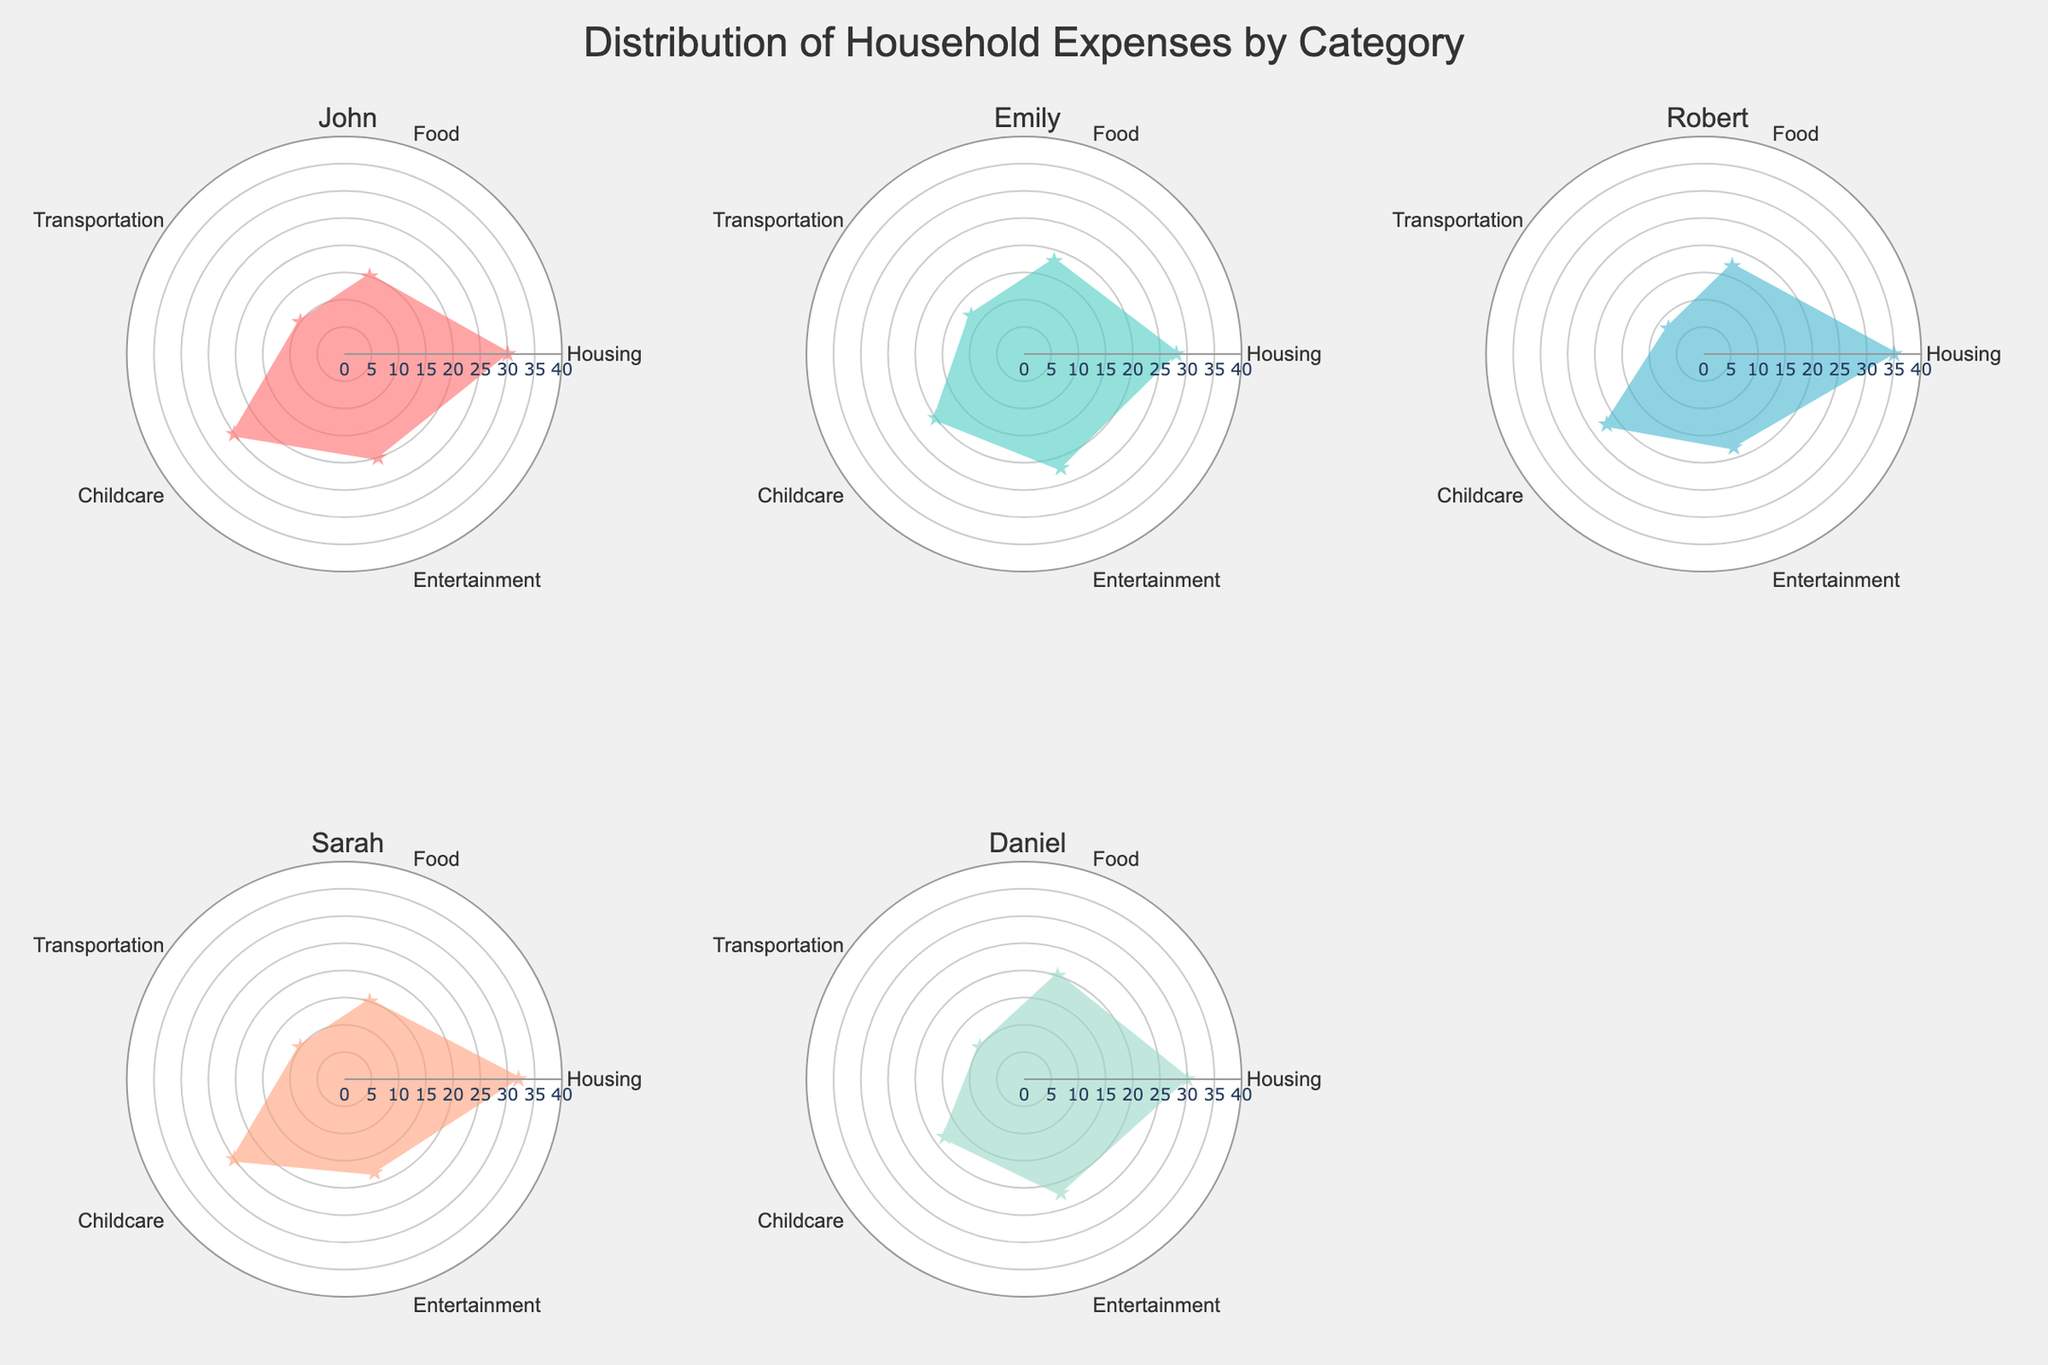What's the title of the figure? The title is located at the top center of the figure and displays the overall topic of the data presented.
Answer: Distribution of Household Expenses by Category How many individuals' household expenses are compared in the figure? By counting the number of subplot titles, one for each individual, we can determine the number of individuals.
Answer: 5 Which individual spends the most on Housing? By comparing the values of Housing for each individual, the one with the highest value is identified. Robert spends 35% on Housing, which is the highest.
Answer: Robert What is the total percentage of expenses for Emily in Food and Childcare? To determine this, add Emily's percentage in Food (18) and Childcare (20).
Answer: 38% Which category has the highest average percentage of expense across all individuals? First, compute the average percentage for each category. Housing: (30+28+35+32+30)/5 = 31, Food: (15+18+17+15+20)/5 = 17, Transportation: (10+12+8+10+10)/5 = 10, Childcare: (25+20+22+25+18)/5 = 22, Entertainment: (20+22+18+18+22)/5 = 20. Then, compare these averages.
Answer: Housing Whose expenses on Entertainment equal those on Housing? By examining the expenses for Entertainment and Housing for each individual, we find that Sarah spends 18% on both categories.
Answer: Sarah Which category shows the highest variability in expenses among individuals? By examining the data closely, we will determine the category with the widest range of values. Housing varies from 28% to 35%, Food from 15% to 20%, Transportation from 8% to 12%, Childcare from 18% to 25%, and Entertainment from 18% to 22%. The highest variability is in Housing (7%).
Answer: Housing What is the difference between Robert's expenses on Childcare and Transportation? Subtract Robert's percentage on Transportation (8) from Childcare (22).
Answer: 14% Which individual has the most balanced expenses across all categories? By looking at the radar charts, we identify the individual whose data points form the most regular polygon, indicating similar values in all categories. Sarah's chart appears the most balanced.
Answer: Sarah What would be the impact on the total percentage of Childcare if Daniel reduced his Childcare expenses by 5%? Daniel's current Childcare expense is 18%. Reducing it by 5% makes it 13%. Recompute the total percentage for Childcare across all individuals: (25+20+22+25+13)/5 = 21.
Answer: 21% 